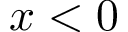<formula> <loc_0><loc_0><loc_500><loc_500>x < 0</formula> 